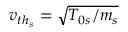<formula> <loc_0><loc_0><loc_500><loc_500>v _ { { t h } _ { s } } = \sqrt { T _ { 0 s } / m _ { s } }</formula> 